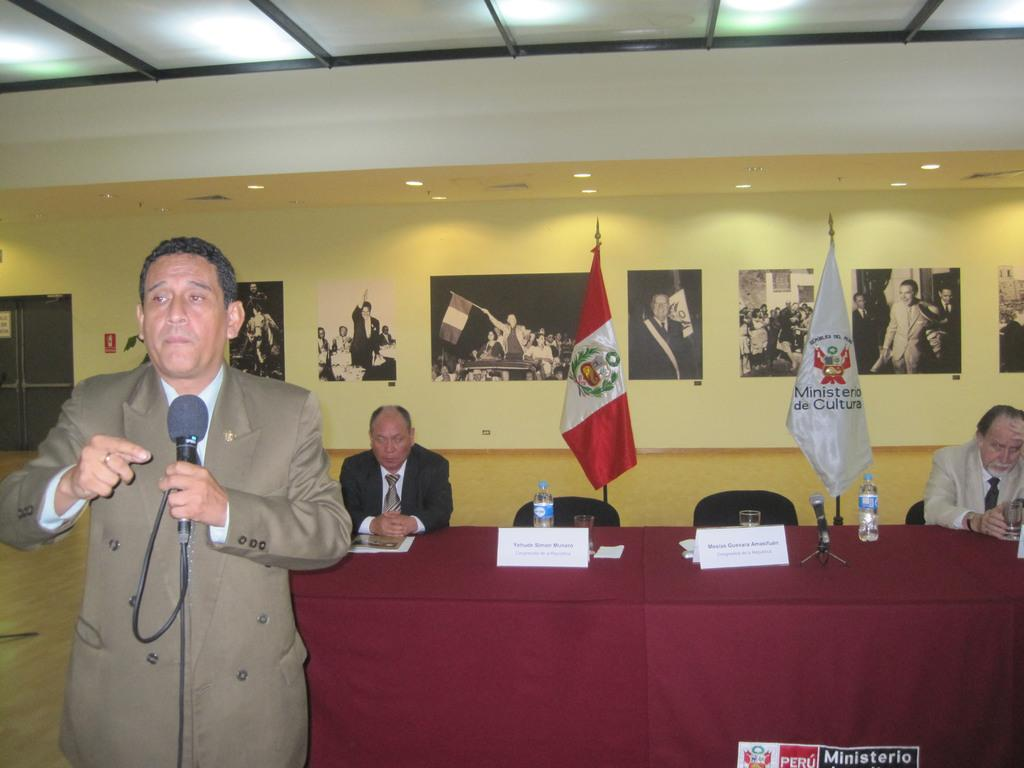Who is the main subject in the image? There is a man in the image. What is the man holding in his hand? The man is holding a mic in his hand. How many other people are in the image? There are two men sitting in chairs in the image. Where are the men located in the image? The men are at a table. What type of lamp is on the table in the image? There is no lamp present in the image; it only features a man holding a mic and two men sitting in chairs at a table. 